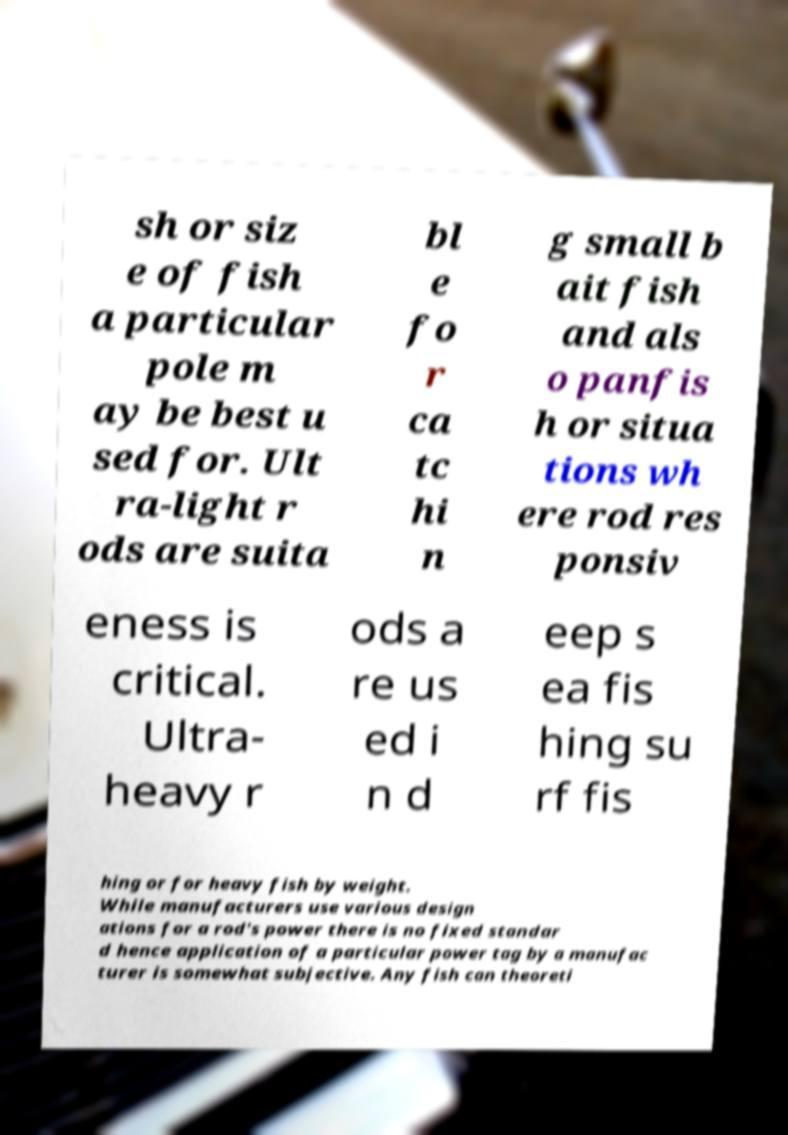For documentation purposes, I need the text within this image transcribed. Could you provide that? sh or siz e of fish a particular pole m ay be best u sed for. Ult ra-light r ods are suita bl e fo r ca tc hi n g small b ait fish and als o panfis h or situa tions wh ere rod res ponsiv eness is critical. Ultra- heavy r ods a re us ed i n d eep s ea fis hing su rf fis hing or for heavy fish by weight. While manufacturers use various design ations for a rod's power there is no fixed standar d hence application of a particular power tag by a manufac turer is somewhat subjective. Any fish can theoreti 